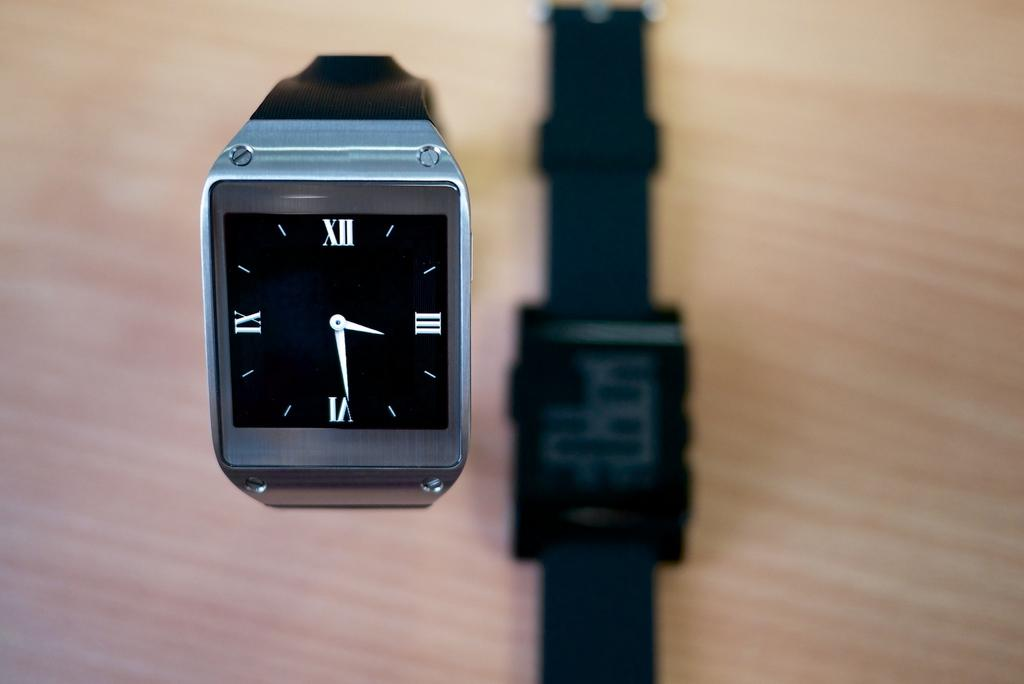<image>
Create a compact narrative representing the image presented. A black and silver watch reads three twenty nine 